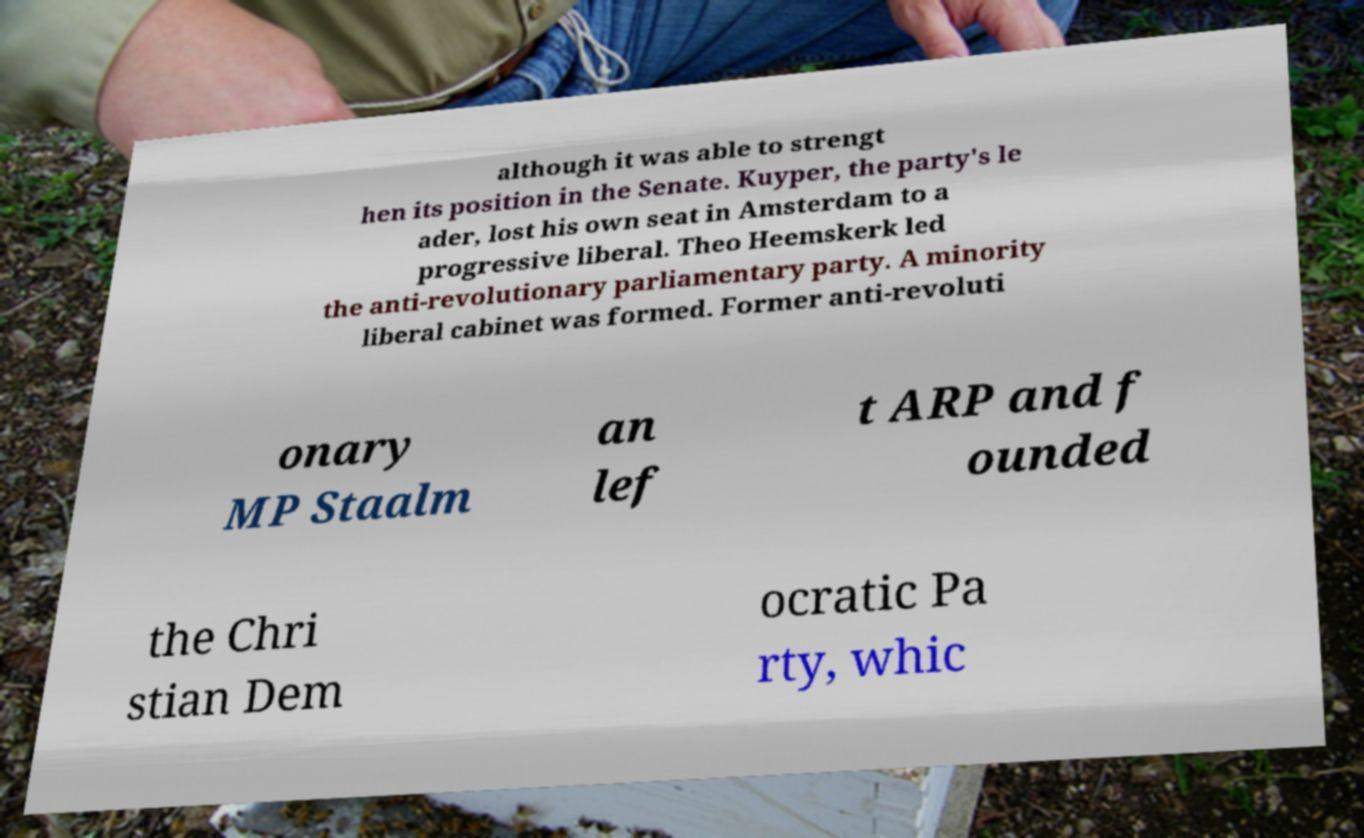Please read and relay the text visible in this image. What does it say? although it was able to strengt hen its position in the Senate. Kuyper, the party's le ader, lost his own seat in Amsterdam to a progressive liberal. Theo Heemskerk led the anti-revolutionary parliamentary party. A minority liberal cabinet was formed. Former anti-revoluti onary MP Staalm an lef t ARP and f ounded the Chri stian Dem ocratic Pa rty, whic 